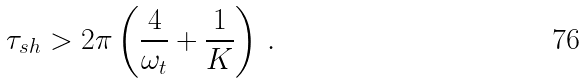Convert formula to latex. <formula><loc_0><loc_0><loc_500><loc_500>\tau _ { s h } > 2 \pi \left ( \frac { 4 } { \omega _ { t } } + \frac { 1 } { K } \right ) \, .</formula> 